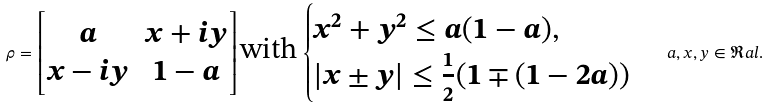Convert formula to latex. <formula><loc_0><loc_0><loc_500><loc_500>\rho = { \begin{bmatrix} a & x + i y \\ x - i y & 1 - a \end{bmatrix} } \, \text {with} \, \begin{cases} x ^ { 2 } + y ^ { 2 } \leq a ( 1 - a ) , \\ | x \pm y | \leq \frac { 1 } { 2 } ( 1 \mp ( 1 - 2 a ) ) \end{cases} \, a , x , y \in \Re a l .</formula> 